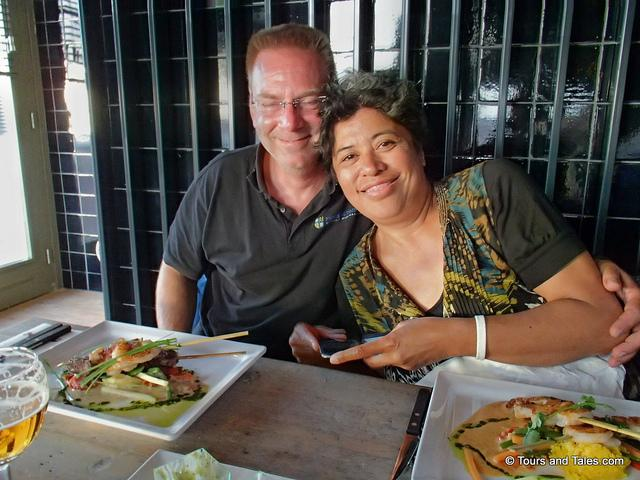How is the man's sight without assistance? Please explain your reasoning. impaired. A man wears glasses. people use glasses to see better. 